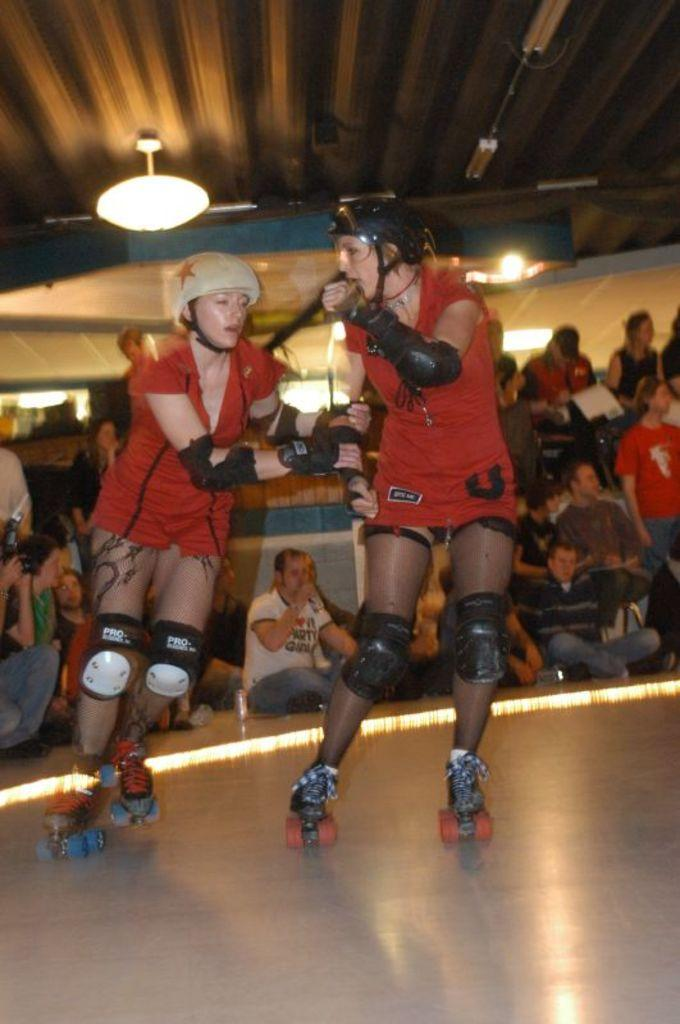What are the two ladies in the image doing? The two ladies are skating on the floor. What can be seen in the background of the image? There are people sitting in the background. What is visible at the top of the image? There are lights visible at the top of the image. What type of metal can be seen on the wing of the skating ladies in the image? There are no wings or metal visible in the image; the ladies are skating on the floor. 